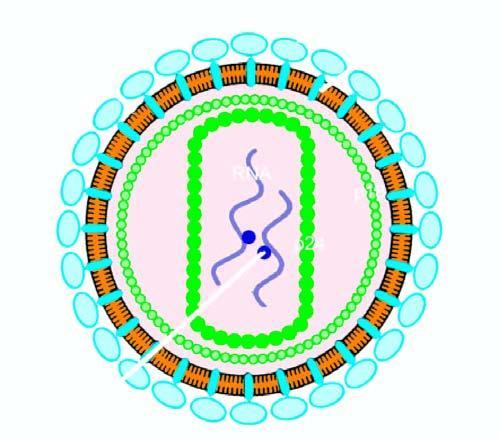s the epidermis studded with 2 viral glycoproteins, gp120 and gp41, in the positions shown?
Answer the question using a single word or phrase. No 